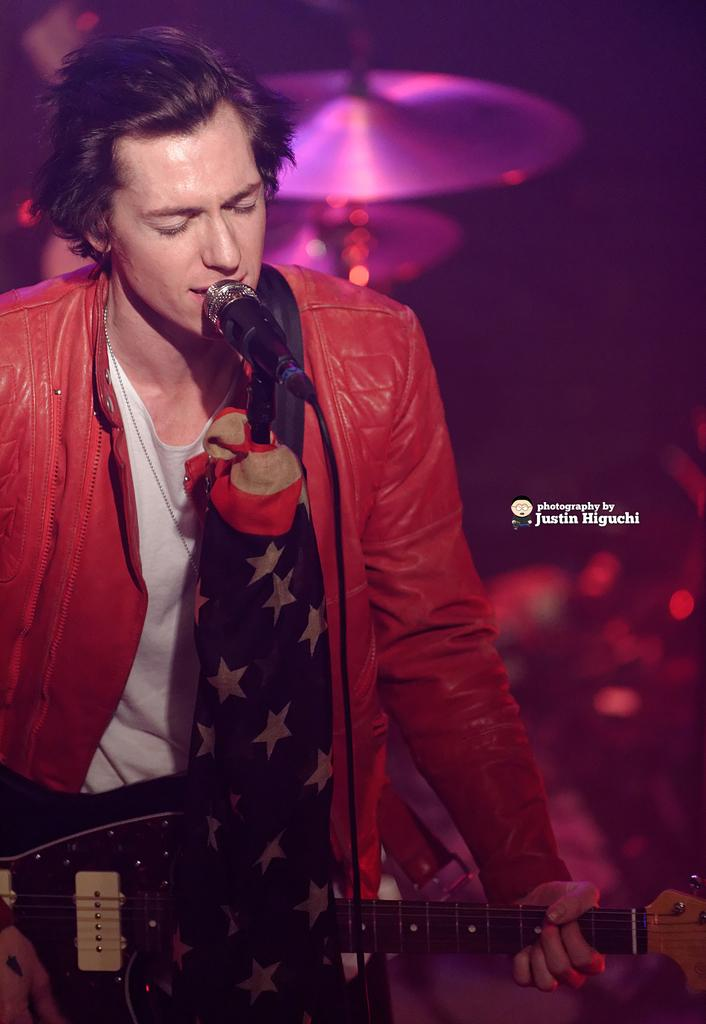Who or what is present in the image? There is a person in the image. What object is the person holding in the image? There is a microphone in the image. What musical instrument can be seen in the image? There is a guitar in the image. How many musical instruments are visible in the image? There are musical instruments in the image, including a guitar. What can be said about the background of the image? The background of the image is dark. What type of camera can be seen in the image? There is no camera present in the image. Can you describe the wheel that is visible in the image? There is no wheel present in the image. 